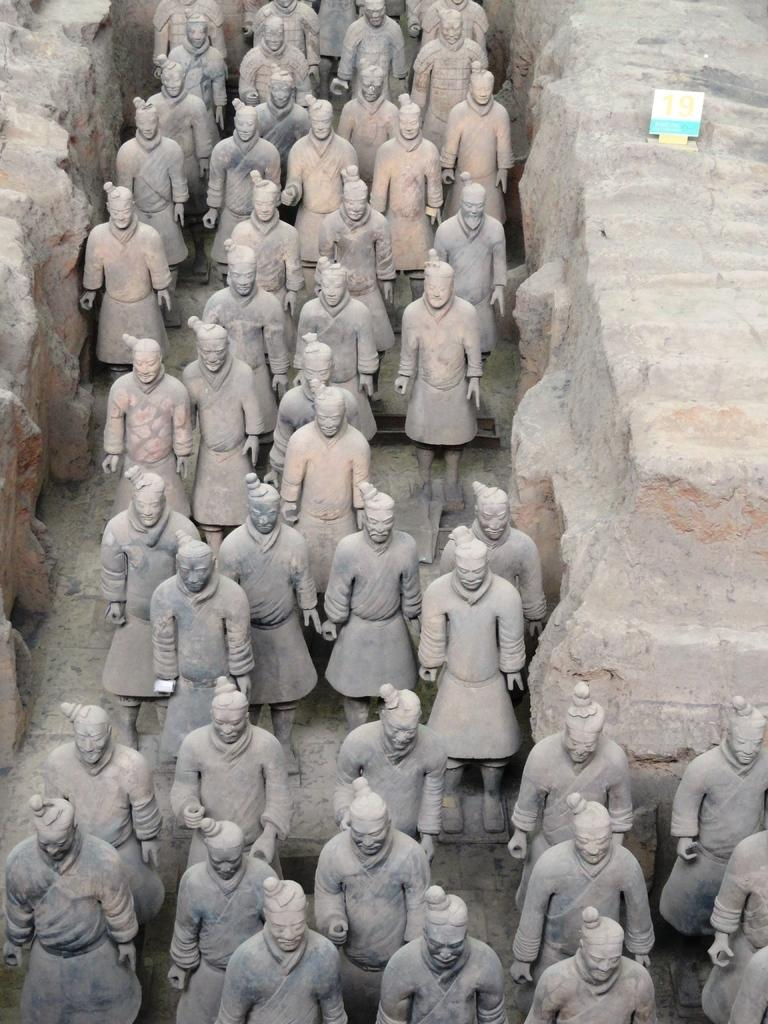What objects are present in the image that resemble living beings? There are statues in the image. What do the statues represent? The statues represent something. What type of vein can be seen running through the statues in the image? There are no veins present in the image, as the statues are likely made of stone or another inanimate material. What appliance is being used by the statues in the image? There is no appliance present in the image, as the statues are stationary and not interacting with any objects. 